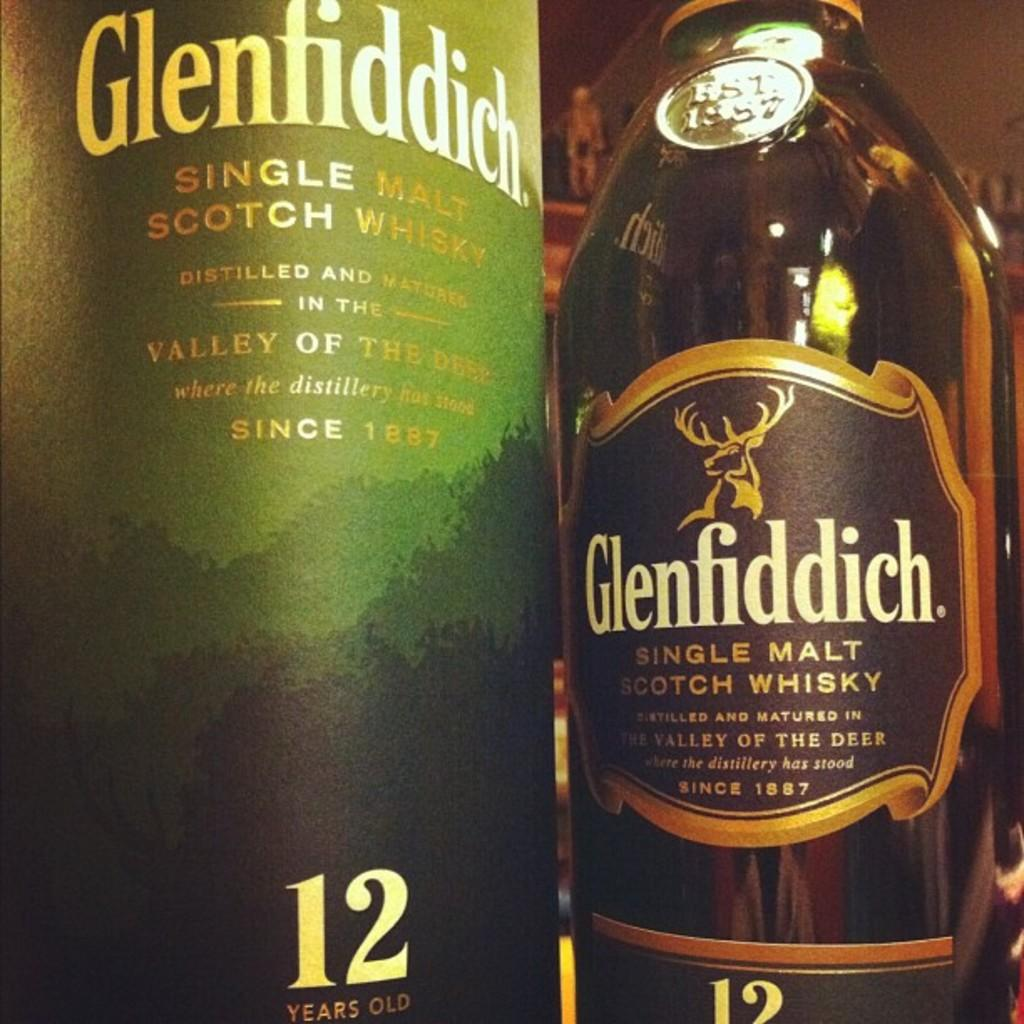Provide a one-sentence caption for the provided image. Two bottles of Glenfiddich, a single malt scotch whisky beverage. 